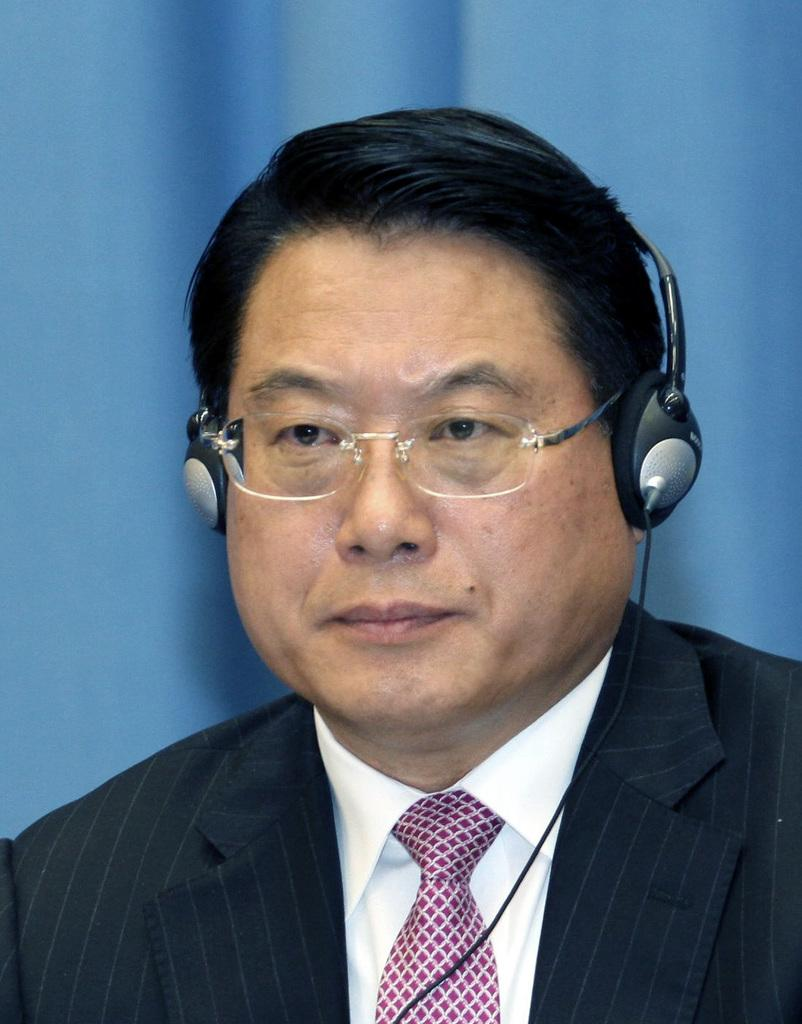What is the main subject of the image? There is a person in the center of the image. What can be seen on the person's head? The person is wearing a headphone. What type of mountain range can be seen in the background of the image? There is no mountain range visible in the image; it only features a person wearing a headphone. What arithmetic problem is the person solving in the image? There is no arithmetic problem present in the image; the person is simply wearing a headphone. 